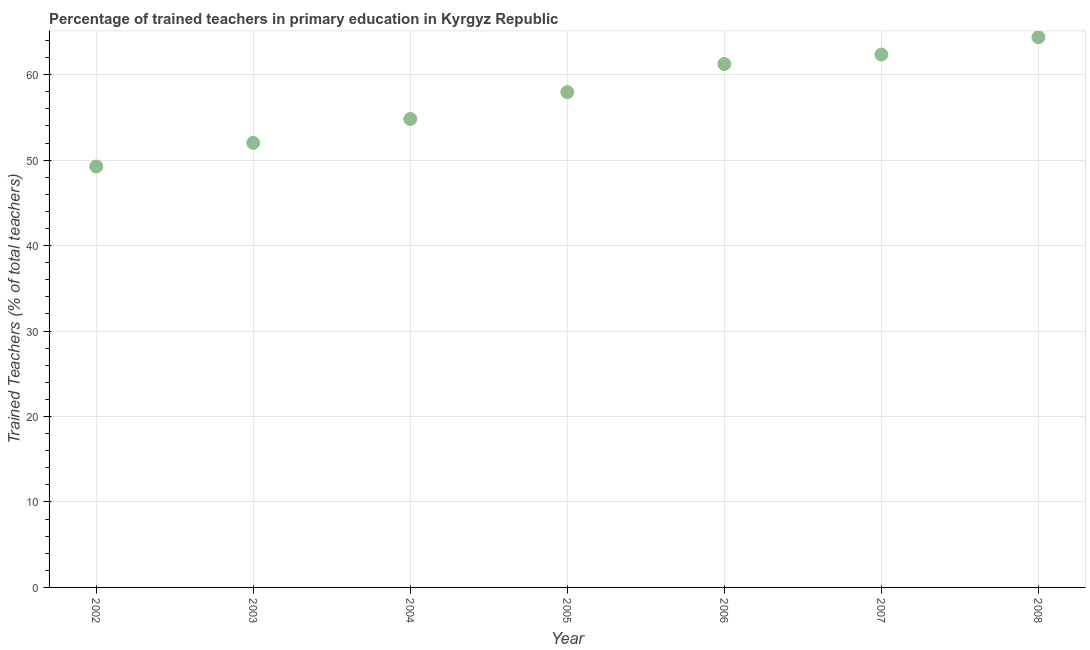What is the percentage of trained teachers in 2005?
Keep it short and to the point. 57.96. Across all years, what is the maximum percentage of trained teachers?
Your answer should be compact. 64.38. Across all years, what is the minimum percentage of trained teachers?
Offer a terse response. 49.26. In which year was the percentage of trained teachers maximum?
Keep it short and to the point. 2008. In which year was the percentage of trained teachers minimum?
Offer a terse response. 2002. What is the sum of the percentage of trained teachers?
Your answer should be compact. 402.05. What is the difference between the percentage of trained teachers in 2002 and 2008?
Make the answer very short. -15.12. What is the average percentage of trained teachers per year?
Keep it short and to the point. 57.44. What is the median percentage of trained teachers?
Your answer should be compact. 57.96. In how many years, is the percentage of trained teachers greater than 40 %?
Provide a succinct answer. 7. Do a majority of the years between 2006 and 2008 (inclusive) have percentage of trained teachers greater than 8 %?
Ensure brevity in your answer.  Yes. What is the ratio of the percentage of trained teachers in 2004 to that in 2007?
Give a very brief answer. 0.88. Is the percentage of trained teachers in 2002 less than that in 2008?
Your answer should be compact. Yes. What is the difference between the highest and the second highest percentage of trained teachers?
Your response must be concise. 2.02. Is the sum of the percentage of trained teachers in 2002 and 2006 greater than the maximum percentage of trained teachers across all years?
Your answer should be compact. Yes. What is the difference between the highest and the lowest percentage of trained teachers?
Your answer should be compact. 15.12. How many years are there in the graph?
Ensure brevity in your answer.  7. What is the difference between two consecutive major ticks on the Y-axis?
Your response must be concise. 10. Are the values on the major ticks of Y-axis written in scientific E-notation?
Give a very brief answer. No. What is the title of the graph?
Provide a succinct answer. Percentage of trained teachers in primary education in Kyrgyz Republic. What is the label or title of the X-axis?
Your answer should be compact. Year. What is the label or title of the Y-axis?
Keep it short and to the point. Trained Teachers (% of total teachers). What is the Trained Teachers (% of total teachers) in 2002?
Offer a very short reply. 49.26. What is the Trained Teachers (% of total teachers) in 2003?
Ensure brevity in your answer.  52.02. What is the Trained Teachers (% of total teachers) in 2004?
Your answer should be compact. 54.82. What is the Trained Teachers (% of total teachers) in 2005?
Provide a short and direct response. 57.96. What is the Trained Teachers (% of total teachers) in 2006?
Ensure brevity in your answer.  61.26. What is the Trained Teachers (% of total teachers) in 2007?
Your response must be concise. 62.36. What is the Trained Teachers (% of total teachers) in 2008?
Offer a terse response. 64.38. What is the difference between the Trained Teachers (% of total teachers) in 2002 and 2003?
Your answer should be compact. -2.76. What is the difference between the Trained Teachers (% of total teachers) in 2002 and 2004?
Ensure brevity in your answer.  -5.56. What is the difference between the Trained Teachers (% of total teachers) in 2002 and 2005?
Offer a very short reply. -8.7. What is the difference between the Trained Teachers (% of total teachers) in 2002 and 2006?
Your answer should be very brief. -12. What is the difference between the Trained Teachers (% of total teachers) in 2002 and 2007?
Make the answer very short. -13.1. What is the difference between the Trained Teachers (% of total teachers) in 2002 and 2008?
Keep it short and to the point. -15.12. What is the difference between the Trained Teachers (% of total teachers) in 2003 and 2004?
Provide a succinct answer. -2.8. What is the difference between the Trained Teachers (% of total teachers) in 2003 and 2005?
Ensure brevity in your answer.  -5.94. What is the difference between the Trained Teachers (% of total teachers) in 2003 and 2006?
Make the answer very short. -9.24. What is the difference between the Trained Teachers (% of total teachers) in 2003 and 2007?
Provide a short and direct response. -10.34. What is the difference between the Trained Teachers (% of total teachers) in 2003 and 2008?
Make the answer very short. -12.36. What is the difference between the Trained Teachers (% of total teachers) in 2004 and 2005?
Provide a succinct answer. -3.14. What is the difference between the Trained Teachers (% of total teachers) in 2004 and 2006?
Your answer should be compact. -6.44. What is the difference between the Trained Teachers (% of total teachers) in 2004 and 2007?
Make the answer very short. -7.54. What is the difference between the Trained Teachers (% of total teachers) in 2004 and 2008?
Give a very brief answer. -9.56. What is the difference between the Trained Teachers (% of total teachers) in 2005 and 2006?
Your answer should be compact. -3.29. What is the difference between the Trained Teachers (% of total teachers) in 2005 and 2007?
Provide a succinct answer. -4.4. What is the difference between the Trained Teachers (% of total teachers) in 2005 and 2008?
Your response must be concise. -6.42. What is the difference between the Trained Teachers (% of total teachers) in 2006 and 2007?
Ensure brevity in your answer.  -1.1. What is the difference between the Trained Teachers (% of total teachers) in 2006 and 2008?
Provide a succinct answer. -3.12. What is the difference between the Trained Teachers (% of total teachers) in 2007 and 2008?
Your response must be concise. -2.02. What is the ratio of the Trained Teachers (% of total teachers) in 2002 to that in 2003?
Give a very brief answer. 0.95. What is the ratio of the Trained Teachers (% of total teachers) in 2002 to that in 2004?
Offer a terse response. 0.9. What is the ratio of the Trained Teachers (% of total teachers) in 2002 to that in 2006?
Your answer should be very brief. 0.8. What is the ratio of the Trained Teachers (% of total teachers) in 2002 to that in 2007?
Provide a succinct answer. 0.79. What is the ratio of the Trained Teachers (% of total teachers) in 2002 to that in 2008?
Your answer should be very brief. 0.77. What is the ratio of the Trained Teachers (% of total teachers) in 2003 to that in 2004?
Provide a succinct answer. 0.95. What is the ratio of the Trained Teachers (% of total teachers) in 2003 to that in 2005?
Offer a very short reply. 0.9. What is the ratio of the Trained Teachers (% of total teachers) in 2003 to that in 2006?
Offer a very short reply. 0.85. What is the ratio of the Trained Teachers (% of total teachers) in 2003 to that in 2007?
Offer a terse response. 0.83. What is the ratio of the Trained Teachers (% of total teachers) in 2003 to that in 2008?
Offer a very short reply. 0.81. What is the ratio of the Trained Teachers (% of total teachers) in 2004 to that in 2005?
Offer a very short reply. 0.95. What is the ratio of the Trained Teachers (% of total teachers) in 2004 to that in 2006?
Your response must be concise. 0.9. What is the ratio of the Trained Teachers (% of total teachers) in 2004 to that in 2007?
Keep it short and to the point. 0.88. What is the ratio of the Trained Teachers (% of total teachers) in 2004 to that in 2008?
Your answer should be compact. 0.85. What is the ratio of the Trained Teachers (% of total teachers) in 2005 to that in 2006?
Offer a terse response. 0.95. What is the ratio of the Trained Teachers (% of total teachers) in 2006 to that in 2008?
Make the answer very short. 0.95. 